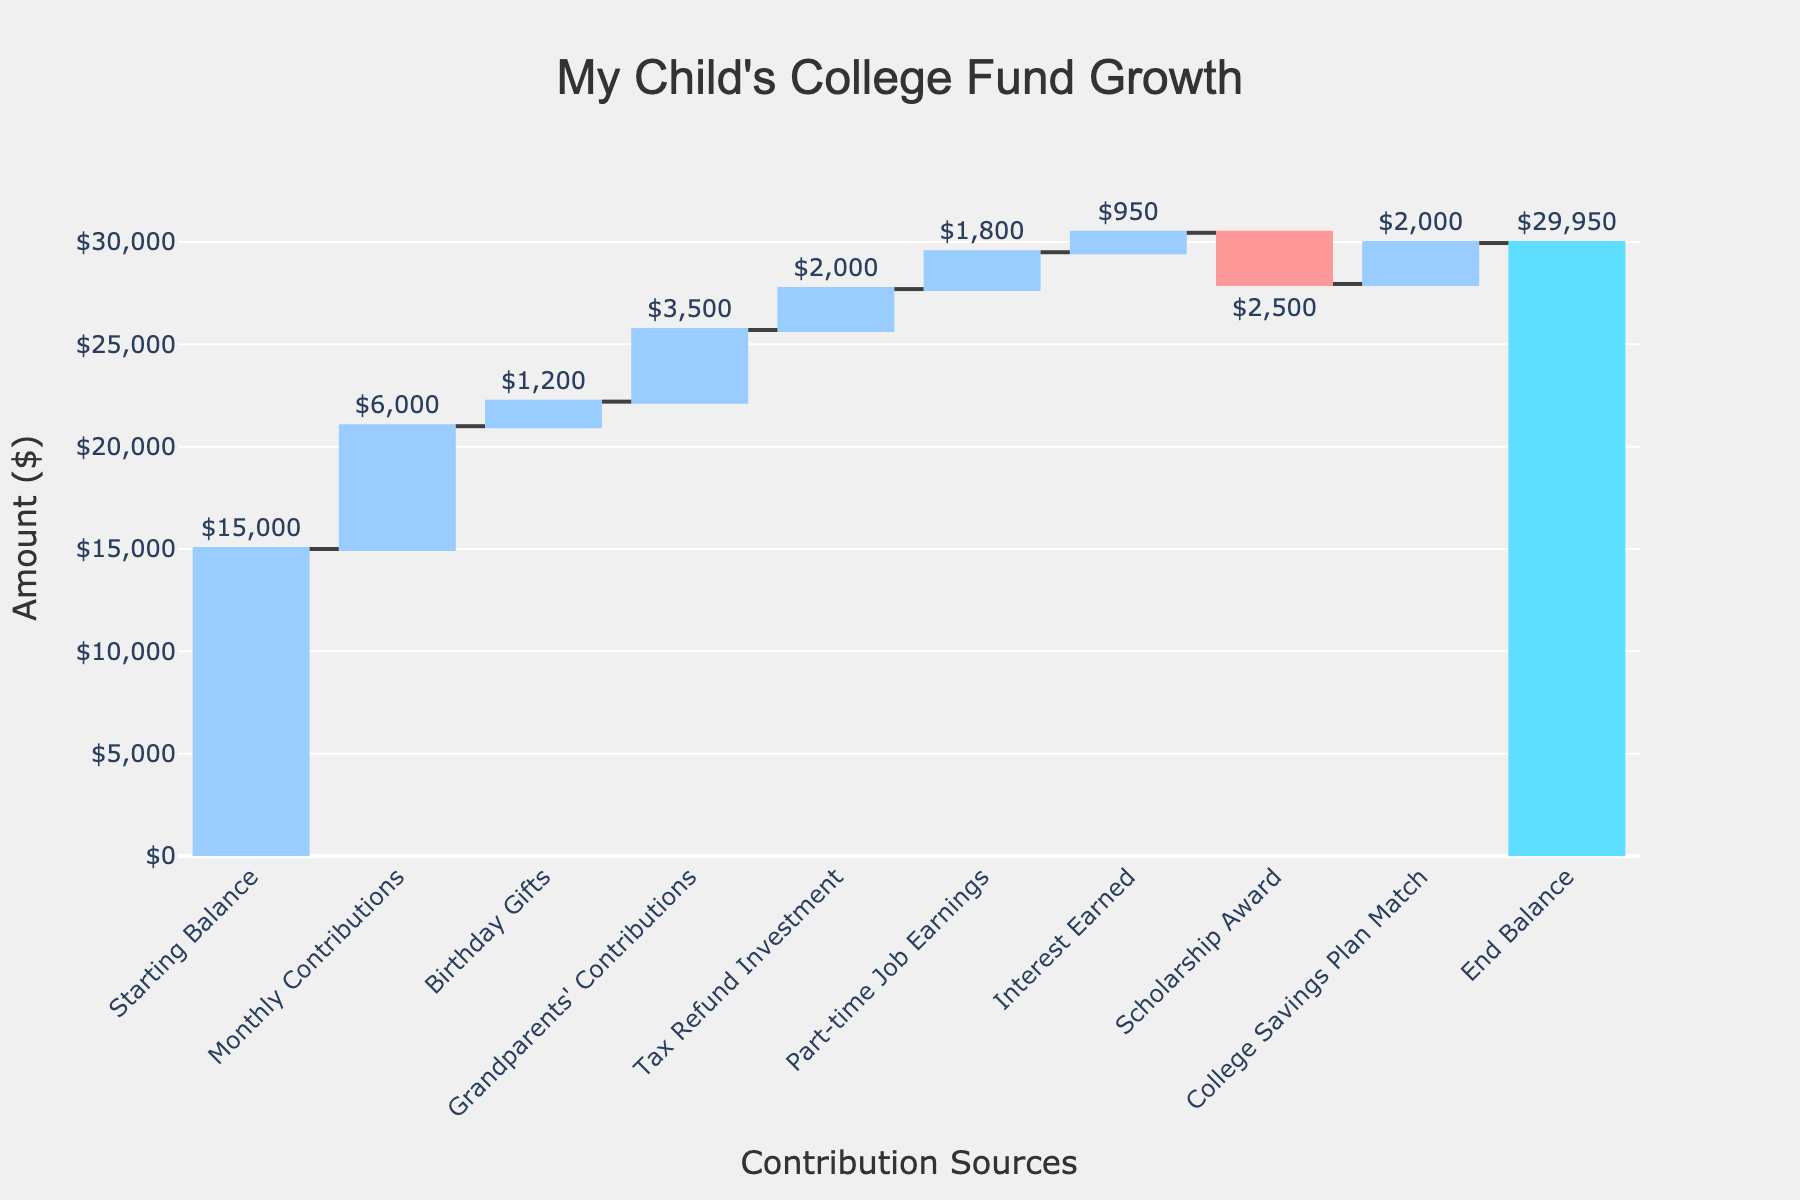What's the title of the figure? The title is located at the top of the figure, indicating the subject of the visualized data.
Answer: My Child's College Fund Growth How many contribution sources are listed before the end balance? Count the entries listed in the x-axis before the "End Balance." Each entry represents a different contribution source. There are 9 entries before the "End Balance."
Answer: 9 Which contribution source had the largest positive impact on the savings? Compare the heights of the "Increasing" bars to determine which one adds the most to the cumulative total. The "Grandparents' Contributions" bar is the tallest among the positive contributions.
Answer: Grandparents' Contributions What was the final end balance for the college fund? The "End Balance" bar at the end of the chart provides the final amount. It is visibly labeled and can be directly read.
Answer: $29,950 Which contribution source decreased the savings? Identify bars that are visually decreasing. The color and direction indicate the contribution source had a negative impact. The "Scholarship Award" is the only negative impact visible.
Answer: Scholarship Award What is the total amount contributed from Birthday Gifts and Part-time Job Earnings? Add the values of "Birthday Gifts" and "Part-time Job Earnings" together. $1200 + $1800 = $3000.
Answer: $3000 Was Monthly Contributions higher or lower than the Tax Refund Investment? Compare the heights of "Monthly Contributions" and "Tax Refund Investment" bars. The "Monthly Contributions" bar is taller than the "Tax Refund Investment" bar.
Answer: Higher What is the difference between the Starting Balance and the final End Balance? Subtract the "Starting Balance" value from the "End Balance" value. $29,950 - $15,000 = $14,950.
Answer: $14,950 What's the total amount contributed by sources other than the starting balance and end balance? Sum all the values except for the "Starting Balance" and "End Balance." $6000 + $1200 + $3500 + $2000 + $1800 + $950 - $2500 + $2000 = $14,950.
Answer: $14,950 Which contribution source had the smallest positive impact on the savings? Compare the heights of the "Increasing" bars and identify which one is the shortest among the positive contributions. The "Interest Earned" bar is the shortest among the positive impacts.
Answer: Interest Earned 